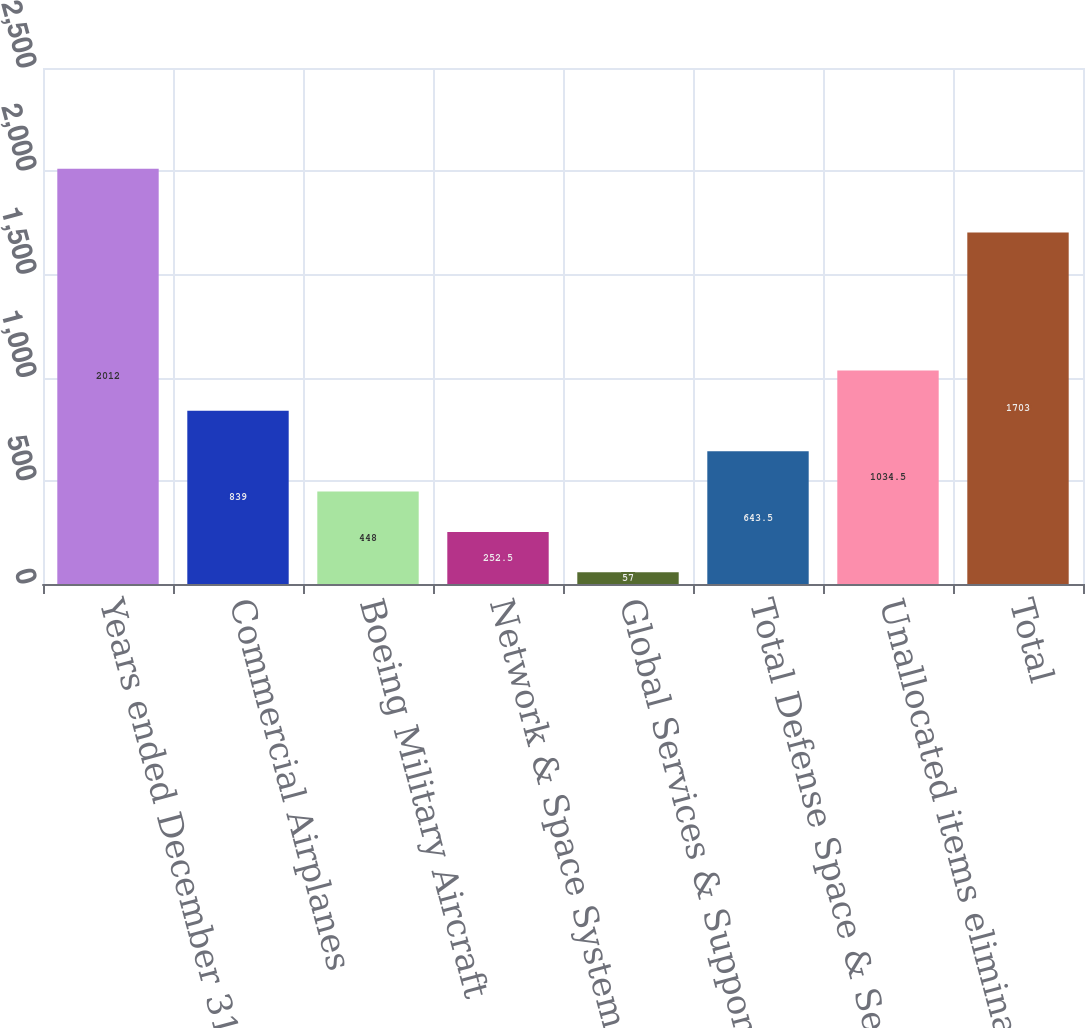Convert chart. <chart><loc_0><loc_0><loc_500><loc_500><bar_chart><fcel>Years ended December 31<fcel>Commercial Airplanes<fcel>Boeing Military Aircraft<fcel>Network & Space Systems<fcel>Global Services & Support<fcel>Total Defense Space & Security<fcel>Unallocated items eliminations<fcel>Total<nl><fcel>2012<fcel>839<fcel>448<fcel>252.5<fcel>57<fcel>643.5<fcel>1034.5<fcel>1703<nl></chart> 